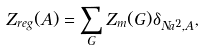<formula> <loc_0><loc_0><loc_500><loc_500>Z _ { r e g } ( A ) = \sum _ { G } Z _ { m } ( G ) \delta _ { N a ^ { 2 } , A } ,</formula> 